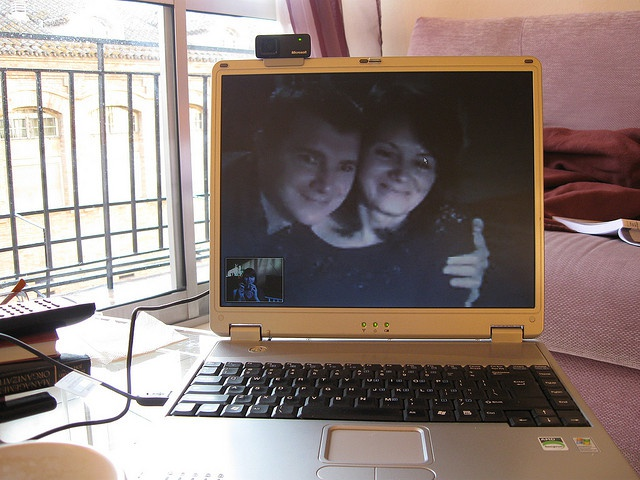Describe the objects in this image and their specific colors. I can see laptop in lightgray, black, gray, and white tones, people in lightgray, black, and gray tones, people in lightgray, black, and gray tones, couch in lightgray, gray, and brown tones, and couch in lightgray, maroon, black, and brown tones in this image. 